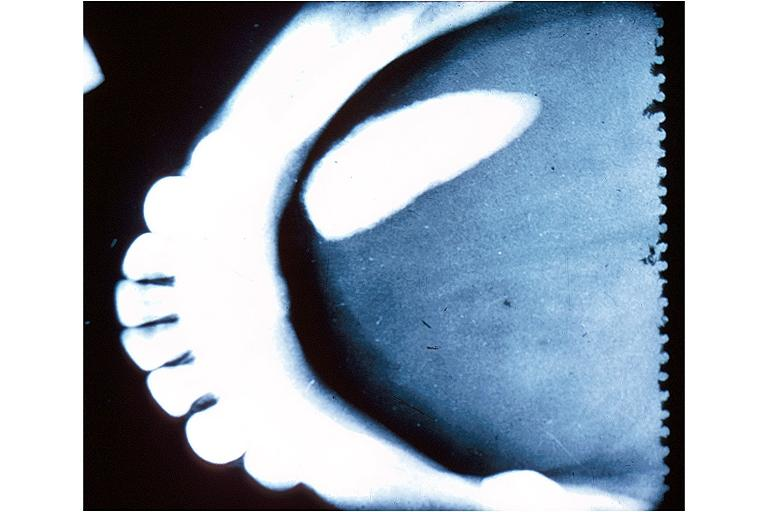what is present?
Answer the question using a single word or phrase. Oral 